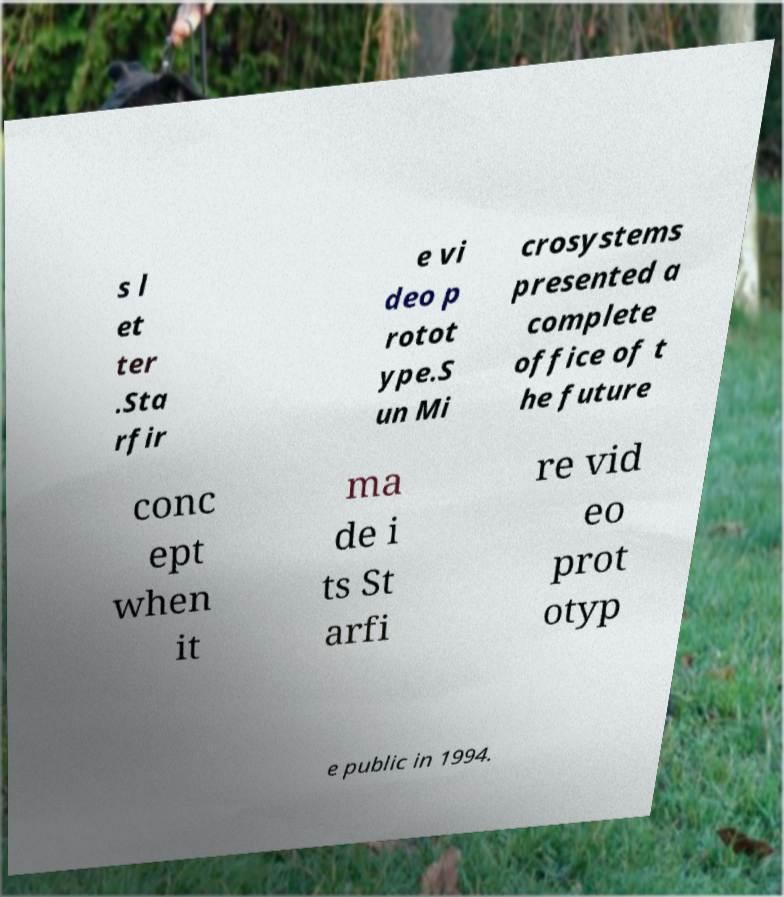For documentation purposes, I need the text within this image transcribed. Could you provide that? s l et ter .Sta rfir e vi deo p rotot ype.S un Mi crosystems presented a complete office of t he future conc ept when it ma de i ts St arfi re vid eo prot otyp e public in 1994. 